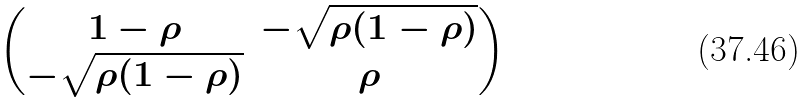<formula> <loc_0><loc_0><loc_500><loc_500>\begin{pmatrix} 1 - \rho & - \sqrt { \rho ( 1 - \rho ) } \\ - \sqrt { \rho ( 1 - \rho ) } & \rho \end{pmatrix}</formula> 